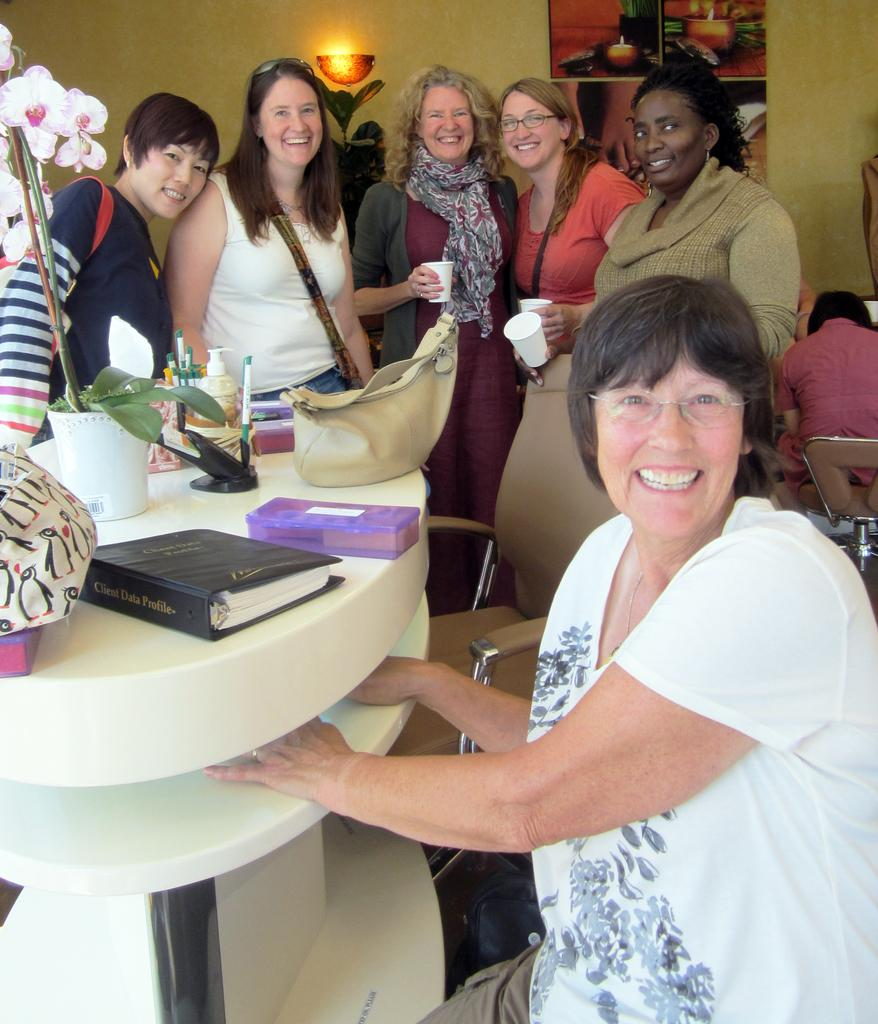<image>
Render a clear and concise summary of the photo. Lady in white smiling in front of a notebook with client data profile in gold. 